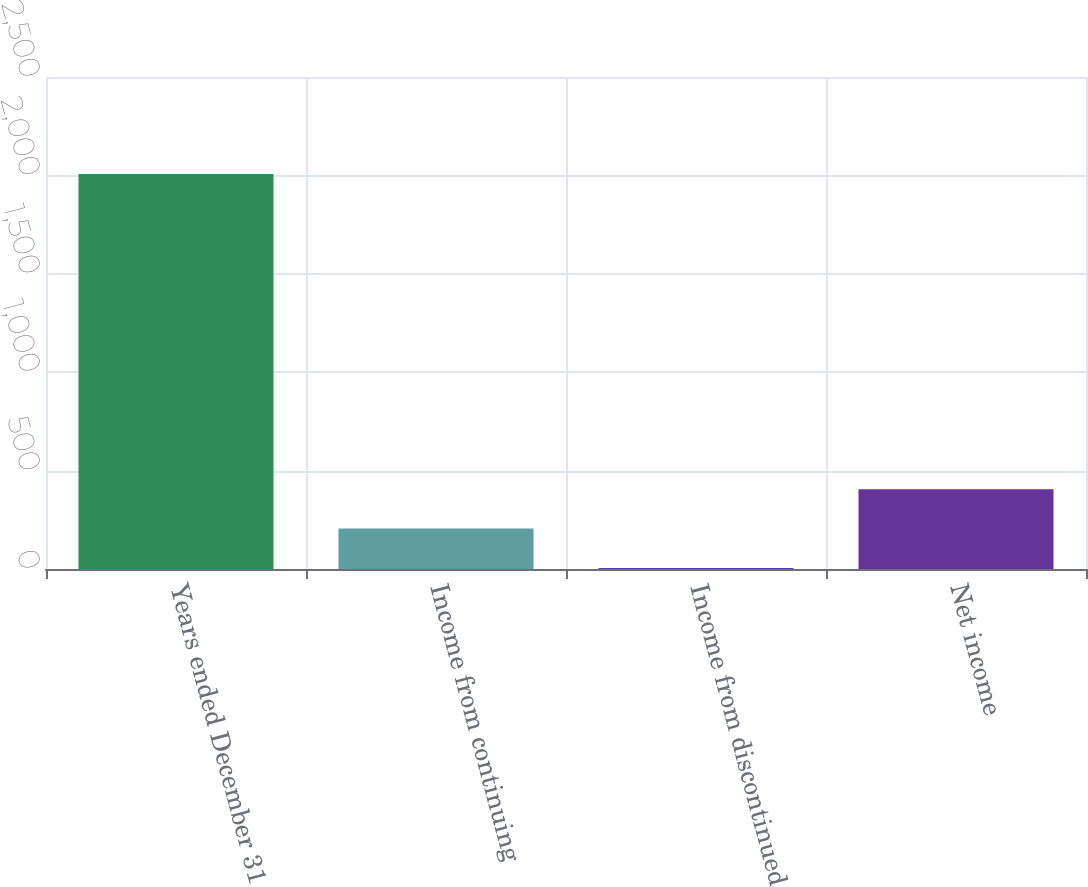Convert chart to OTSL. <chart><loc_0><loc_0><loc_500><loc_500><bar_chart><fcel>Years ended December 31<fcel>Income from continuing<fcel>Income from discontinued<fcel>Net income<nl><fcel>2007<fcel>205.2<fcel>5<fcel>405.4<nl></chart> 